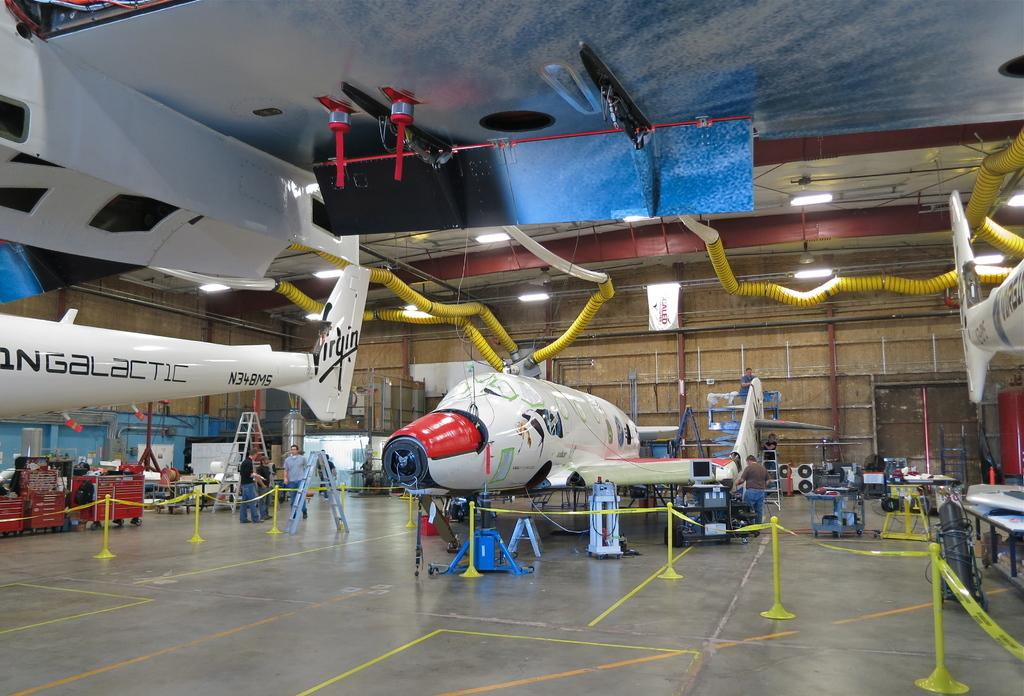<image>
Offer a succinct explanation of the picture presented. A Galactic airplane and another plane are in the hangar. 